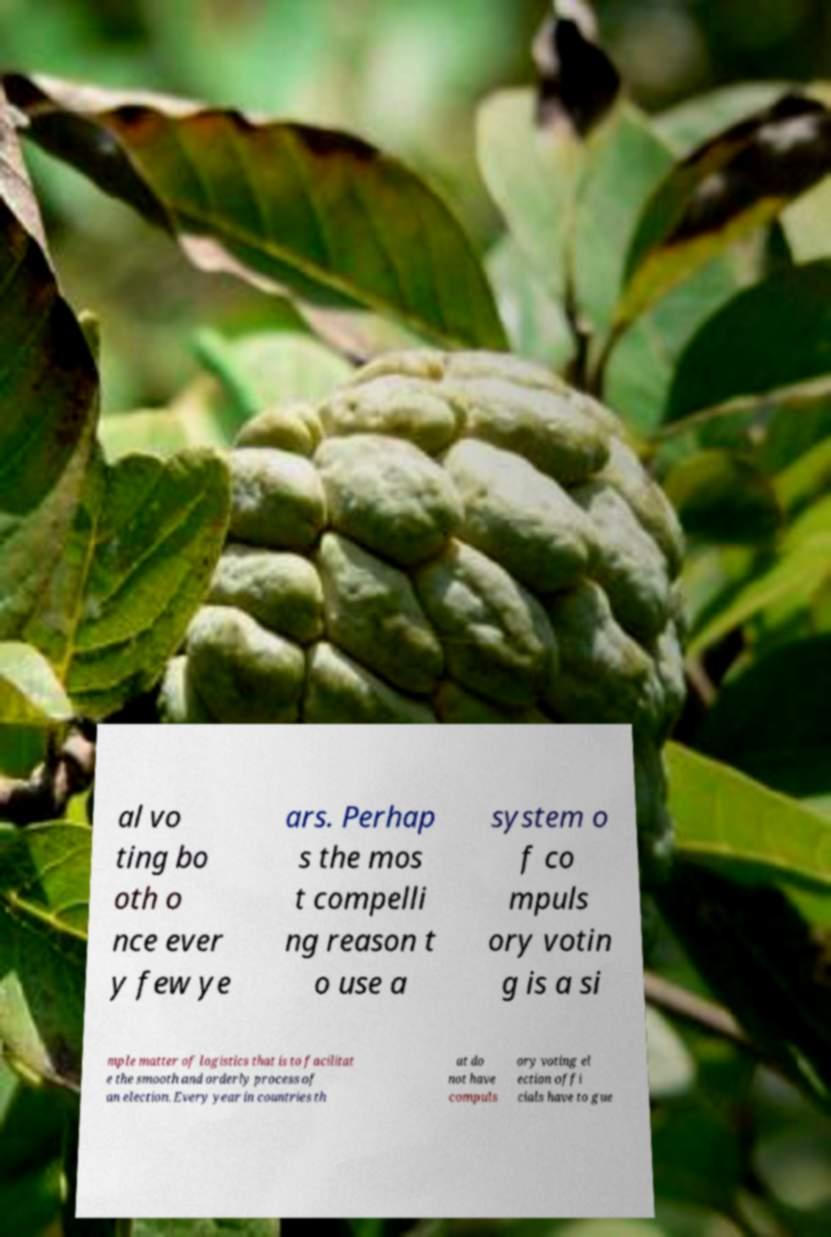Can you accurately transcribe the text from the provided image for me? al vo ting bo oth o nce ever y few ye ars. Perhap s the mos t compelli ng reason t o use a system o f co mpuls ory votin g is a si mple matter of logistics that is to facilitat e the smooth and orderly process of an election. Every year in countries th at do not have compuls ory voting el ection offi cials have to gue 